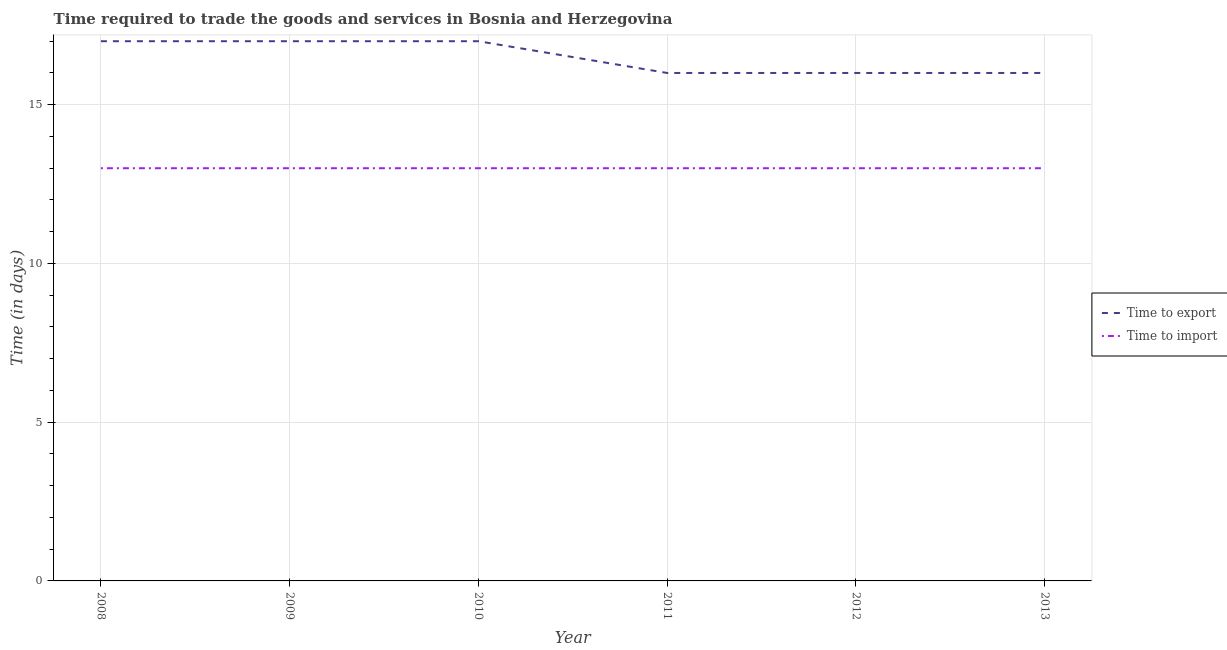How many different coloured lines are there?
Your response must be concise. 2. Is the number of lines equal to the number of legend labels?
Give a very brief answer. Yes. What is the time to export in 2010?
Ensure brevity in your answer.  17. Across all years, what is the maximum time to import?
Your answer should be compact. 13. Across all years, what is the minimum time to import?
Keep it short and to the point. 13. In which year was the time to export maximum?
Your answer should be compact. 2008. What is the total time to import in the graph?
Keep it short and to the point. 78. What is the difference between the time to export in 2009 and that in 2011?
Give a very brief answer. 1. What is the difference between the time to import in 2012 and the time to export in 2008?
Provide a short and direct response. -4. What is the average time to import per year?
Your response must be concise. 13. In the year 2008, what is the difference between the time to export and time to import?
Give a very brief answer. 4. What is the ratio of the time to import in 2011 to that in 2013?
Your answer should be very brief. 1. Is the difference between the time to import in 2011 and 2013 greater than the difference between the time to export in 2011 and 2013?
Provide a short and direct response. No. What is the difference between the highest and the lowest time to export?
Your response must be concise. 1. In how many years, is the time to import greater than the average time to import taken over all years?
Your answer should be compact. 0. Does the time to export monotonically increase over the years?
Ensure brevity in your answer.  No. Is the time to import strictly greater than the time to export over the years?
Keep it short and to the point. No. How many years are there in the graph?
Provide a short and direct response. 6. Does the graph contain grids?
Ensure brevity in your answer.  Yes. How are the legend labels stacked?
Provide a short and direct response. Vertical. What is the title of the graph?
Make the answer very short. Time required to trade the goods and services in Bosnia and Herzegovina. What is the label or title of the X-axis?
Offer a very short reply. Year. What is the label or title of the Y-axis?
Keep it short and to the point. Time (in days). What is the Time (in days) in Time to import in 2008?
Your answer should be very brief. 13. What is the Time (in days) in Time to export in 2009?
Provide a short and direct response. 17. What is the Time (in days) in Time to import in 2009?
Provide a short and direct response. 13. What is the Time (in days) in Time to import in 2010?
Make the answer very short. 13. What is the Time (in days) of Time to import in 2011?
Your answer should be compact. 13. What is the Time (in days) in Time to import in 2012?
Ensure brevity in your answer.  13. What is the Time (in days) in Time to import in 2013?
Give a very brief answer. 13. Across all years, what is the maximum Time (in days) of Time to import?
Your response must be concise. 13. Across all years, what is the minimum Time (in days) in Time to export?
Your answer should be very brief. 16. What is the total Time (in days) in Time to export in the graph?
Ensure brevity in your answer.  99. What is the difference between the Time (in days) of Time to export in 2008 and that in 2009?
Ensure brevity in your answer.  0. What is the difference between the Time (in days) of Time to import in 2008 and that in 2009?
Your answer should be very brief. 0. What is the difference between the Time (in days) of Time to export in 2008 and that in 2011?
Keep it short and to the point. 1. What is the difference between the Time (in days) in Time to import in 2008 and that in 2011?
Keep it short and to the point. 0. What is the difference between the Time (in days) of Time to export in 2008 and that in 2012?
Your response must be concise. 1. What is the difference between the Time (in days) in Time to import in 2008 and that in 2013?
Your answer should be compact. 0. What is the difference between the Time (in days) in Time to import in 2009 and that in 2010?
Keep it short and to the point. 0. What is the difference between the Time (in days) in Time to export in 2009 and that in 2011?
Keep it short and to the point. 1. What is the difference between the Time (in days) in Time to import in 2009 and that in 2011?
Provide a succinct answer. 0. What is the difference between the Time (in days) of Time to import in 2009 and that in 2013?
Keep it short and to the point. 0. What is the difference between the Time (in days) of Time to export in 2010 and that in 2011?
Offer a terse response. 1. What is the difference between the Time (in days) of Time to import in 2010 and that in 2011?
Offer a terse response. 0. What is the difference between the Time (in days) in Time to import in 2010 and that in 2012?
Offer a very short reply. 0. What is the difference between the Time (in days) in Time to export in 2011 and that in 2013?
Your answer should be compact. 0. What is the difference between the Time (in days) in Time to import in 2011 and that in 2013?
Provide a succinct answer. 0. What is the difference between the Time (in days) in Time to import in 2012 and that in 2013?
Keep it short and to the point. 0. What is the difference between the Time (in days) in Time to export in 2008 and the Time (in days) in Time to import in 2009?
Give a very brief answer. 4. What is the difference between the Time (in days) of Time to export in 2008 and the Time (in days) of Time to import in 2010?
Keep it short and to the point. 4. What is the difference between the Time (in days) of Time to export in 2008 and the Time (in days) of Time to import in 2013?
Provide a succinct answer. 4. What is the difference between the Time (in days) of Time to export in 2009 and the Time (in days) of Time to import in 2010?
Keep it short and to the point. 4. What is the difference between the Time (in days) in Time to export in 2009 and the Time (in days) in Time to import in 2012?
Offer a terse response. 4. What is the difference between the Time (in days) of Time to export in 2009 and the Time (in days) of Time to import in 2013?
Your answer should be compact. 4. What is the difference between the Time (in days) in Time to export in 2010 and the Time (in days) in Time to import in 2012?
Your response must be concise. 4. What is the difference between the Time (in days) of Time to export in 2010 and the Time (in days) of Time to import in 2013?
Give a very brief answer. 4. What is the difference between the Time (in days) in Time to export in 2011 and the Time (in days) in Time to import in 2012?
Your response must be concise. 3. What is the difference between the Time (in days) in Time to export in 2011 and the Time (in days) in Time to import in 2013?
Give a very brief answer. 3. What is the difference between the Time (in days) of Time to export in 2012 and the Time (in days) of Time to import in 2013?
Keep it short and to the point. 3. What is the average Time (in days) in Time to import per year?
Provide a succinct answer. 13. In the year 2008, what is the difference between the Time (in days) in Time to export and Time (in days) in Time to import?
Keep it short and to the point. 4. In the year 2009, what is the difference between the Time (in days) in Time to export and Time (in days) in Time to import?
Make the answer very short. 4. In the year 2011, what is the difference between the Time (in days) in Time to export and Time (in days) in Time to import?
Your response must be concise. 3. In the year 2012, what is the difference between the Time (in days) in Time to export and Time (in days) in Time to import?
Provide a succinct answer. 3. In the year 2013, what is the difference between the Time (in days) of Time to export and Time (in days) of Time to import?
Provide a succinct answer. 3. What is the ratio of the Time (in days) of Time to export in 2008 to that in 2010?
Keep it short and to the point. 1. What is the ratio of the Time (in days) of Time to import in 2008 to that in 2010?
Make the answer very short. 1. What is the ratio of the Time (in days) in Time to export in 2008 to that in 2011?
Provide a short and direct response. 1.06. What is the ratio of the Time (in days) in Time to import in 2008 to that in 2011?
Make the answer very short. 1. What is the ratio of the Time (in days) in Time to export in 2008 to that in 2012?
Provide a succinct answer. 1.06. What is the ratio of the Time (in days) of Time to export in 2008 to that in 2013?
Give a very brief answer. 1.06. What is the ratio of the Time (in days) in Time to import in 2008 to that in 2013?
Your answer should be very brief. 1. What is the ratio of the Time (in days) in Time to export in 2009 to that in 2010?
Give a very brief answer. 1. What is the ratio of the Time (in days) in Time to import in 2009 to that in 2010?
Your response must be concise. 1. What is the ratio of the Time (in days) in Time to export in 2009 to that in 2011?
Provide a short and direct response. 1.06. What is the ratio of the Time (in days) of Time to import in 2009 to that in 2011?
Make the answer very short. 1. What is the ratio of the Time (in days) of Time to export in 2009 to that in 2012?
Your response must be concise. 1.06. What is the ratio of the Time (in days) of Time to import in 2009 to that in 2013?
Offer a terse response. 1. What is the ratio of the Time (in days) in Time to export in 2010 to that in 2011?
Give a very brief answer. 1.06. What is the ratio of the Time (in days) in Time to import in 2010 to that in 2011?
Your answer should be compact. 1. What is the ratio of the Time (in days) of Time to export in 2010 to that in 2013?
Your answer should be very brief. 1.06. What is the ratio of the Time (in days) of Time to import in 2010 to that in 2013?
Provide a succinct answer. 1. What is the ratio of the Time (in days) of Time to export in 2011 to that in 2013?
Keep it short and to the point. 1. What is the ratio of the Time (in days) of Time to import in 2011 to that in 2013?
Keep it short and to the point. 1. What is the ratio of the Time (in days) of Time to export in 2012 to that in 2013?
Your answer should be very brief. 1. What is the ratio of the Time (in days) of Time to import in 2012 to that in 2013?
Provide a succinct answer. 1. 